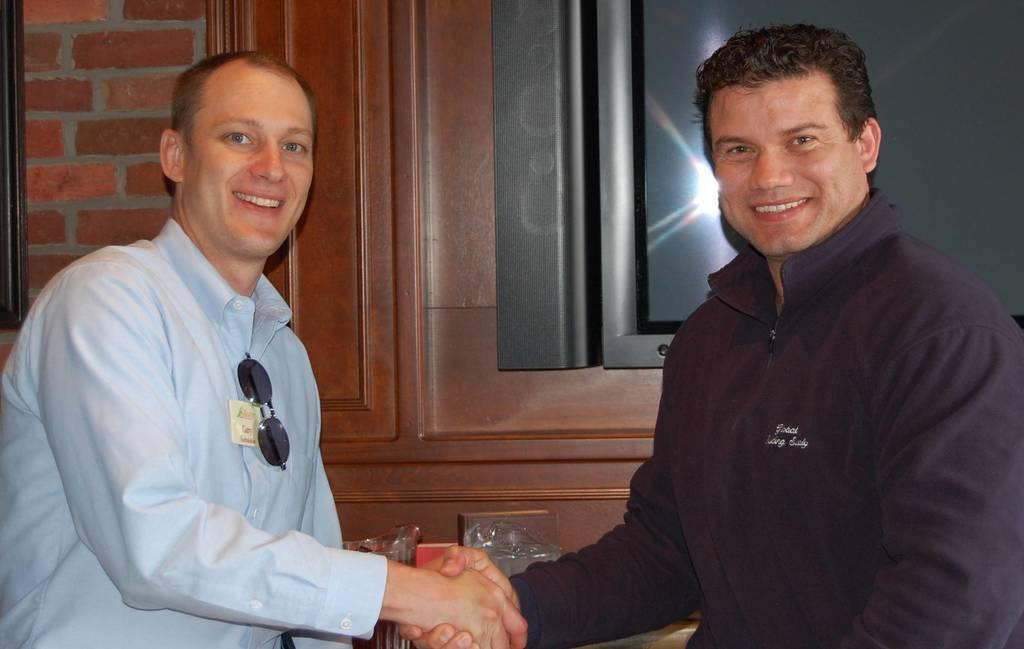How many people are in the image? There are two men in the image. What are the men doing in the image? The men are shaking hands. What can be seen in the background of the image? There are glass objects, a TV, and a brick wall in the background of the image. What type of machine is being used by the men in the image? There is no machine present in the image; the men are simply shaking hands. What language are the men speaking in the image? The image does not provide any information about the language being spoken by the men. 